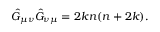Convert formula to latex. <formula><loc_0><loc_0><loc_500><loc_500>\hat { G } _ { \mu \nu } \hat { G } _ { \nu \mu } = 2 k n ( n + 2 k ) .</formula> 